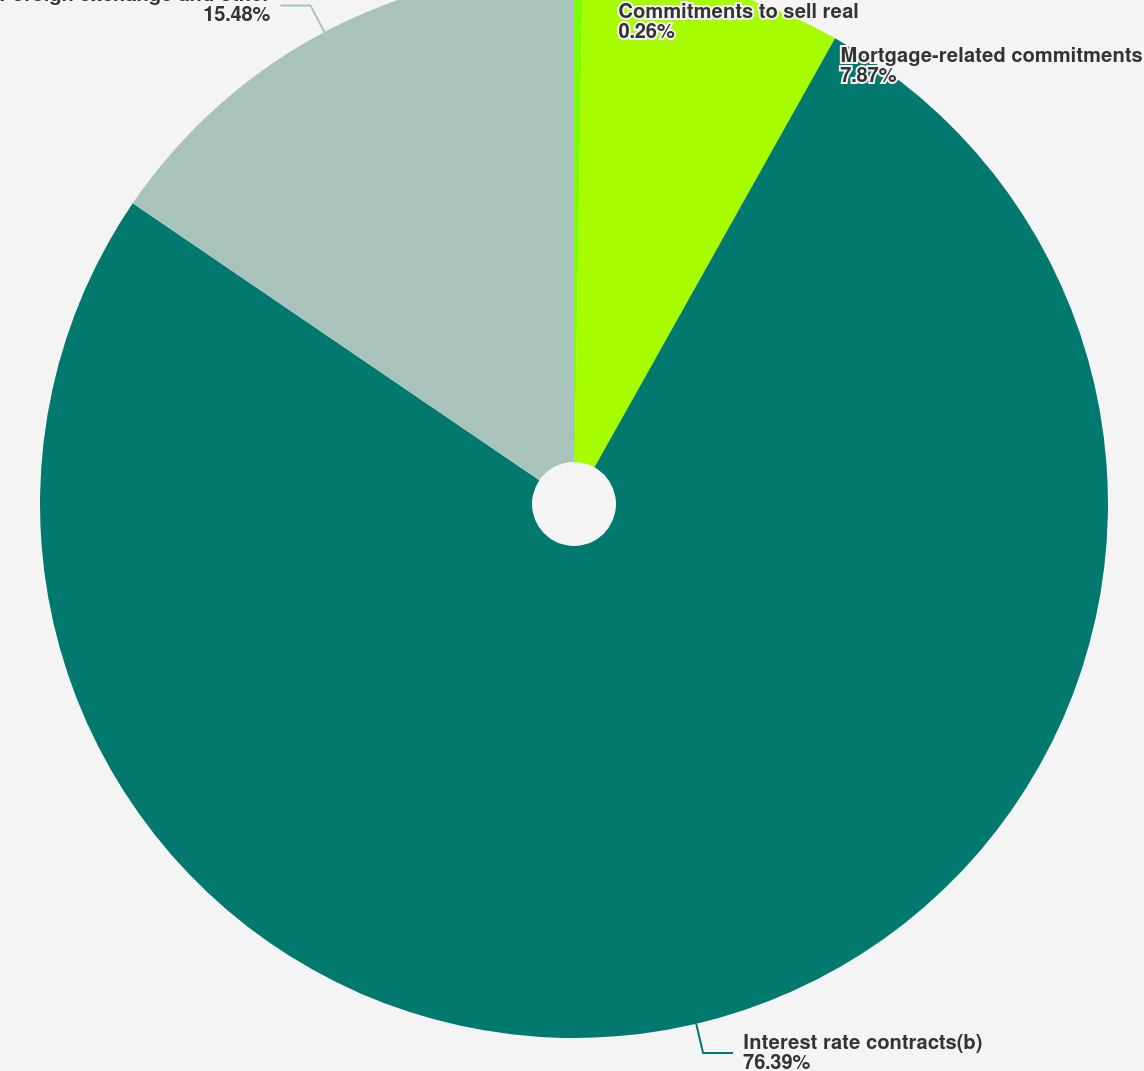Convert chart. <chart><loc_0><loc_0><loc_500><loc_500><pie_chart><fcel>Commitments to sell real<fcel>Mortgage-related commitments<fcel>Interest rate contracts(b)<fcel>Foreign exchange and other<nl><fcel>0.26%<fcel>7.87%<fcel>76.39%<fcel>15.48%<nl></chart> 